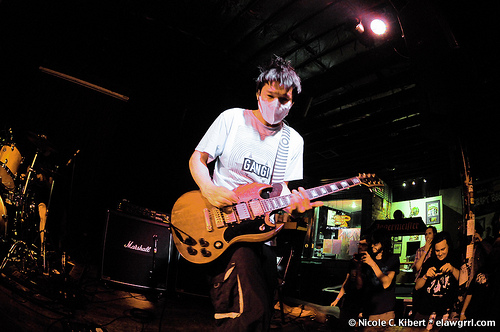<image>
Is the mask on the guitarist? Yes. Looking at the image, I can see the mask is positioned on top of the guitarist, with the guitarist providing support. 